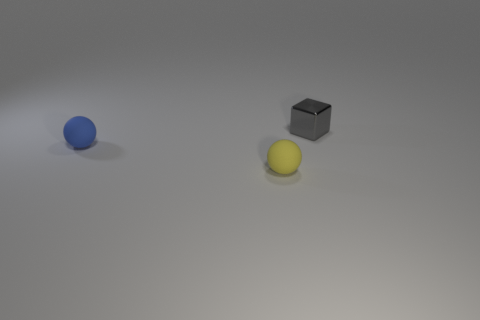What number of other things are the same color as the metal block?
Keep it short and to the point. 0. Does the ball to the right of the blue thing have the same size as the metal thing that is right of the yellow sphere?
Offer a terse response. Yes. Are there the same number of small blocks on the left side of the tiny metal thing and small spheres that are in front of the blue matte sphere?
Provide a short and direct response. No. Is there anything else that has the same material as the gray object?
Offer a terse response. No. Do the yellow rubber ball and the rubber sphere behind the tiny yellow matte sphere have the same size?
Give a very brief answer. Yes. There is a ball that is on the left side of the matte object on the right side of the small blue matte ball; what is it made of?
Give a very brief answer. Rubber. Are there the same number of yellow objects that are in front of the tiny yellow sphere and shiny blocks?
Ensure brevity in your answer.  No. There is a object that is both in front of the tiny gray object and behind the small yellow sphere; what size is it?
Keep it short and to the point. Small. There is a rubber ball behind the matte sphere that is in front of the blue thing; what is its color?
Provide a short and direct response. Blue. What number of red things are metal cylinders or tiny objects?
Offer a very short reply. 0. 